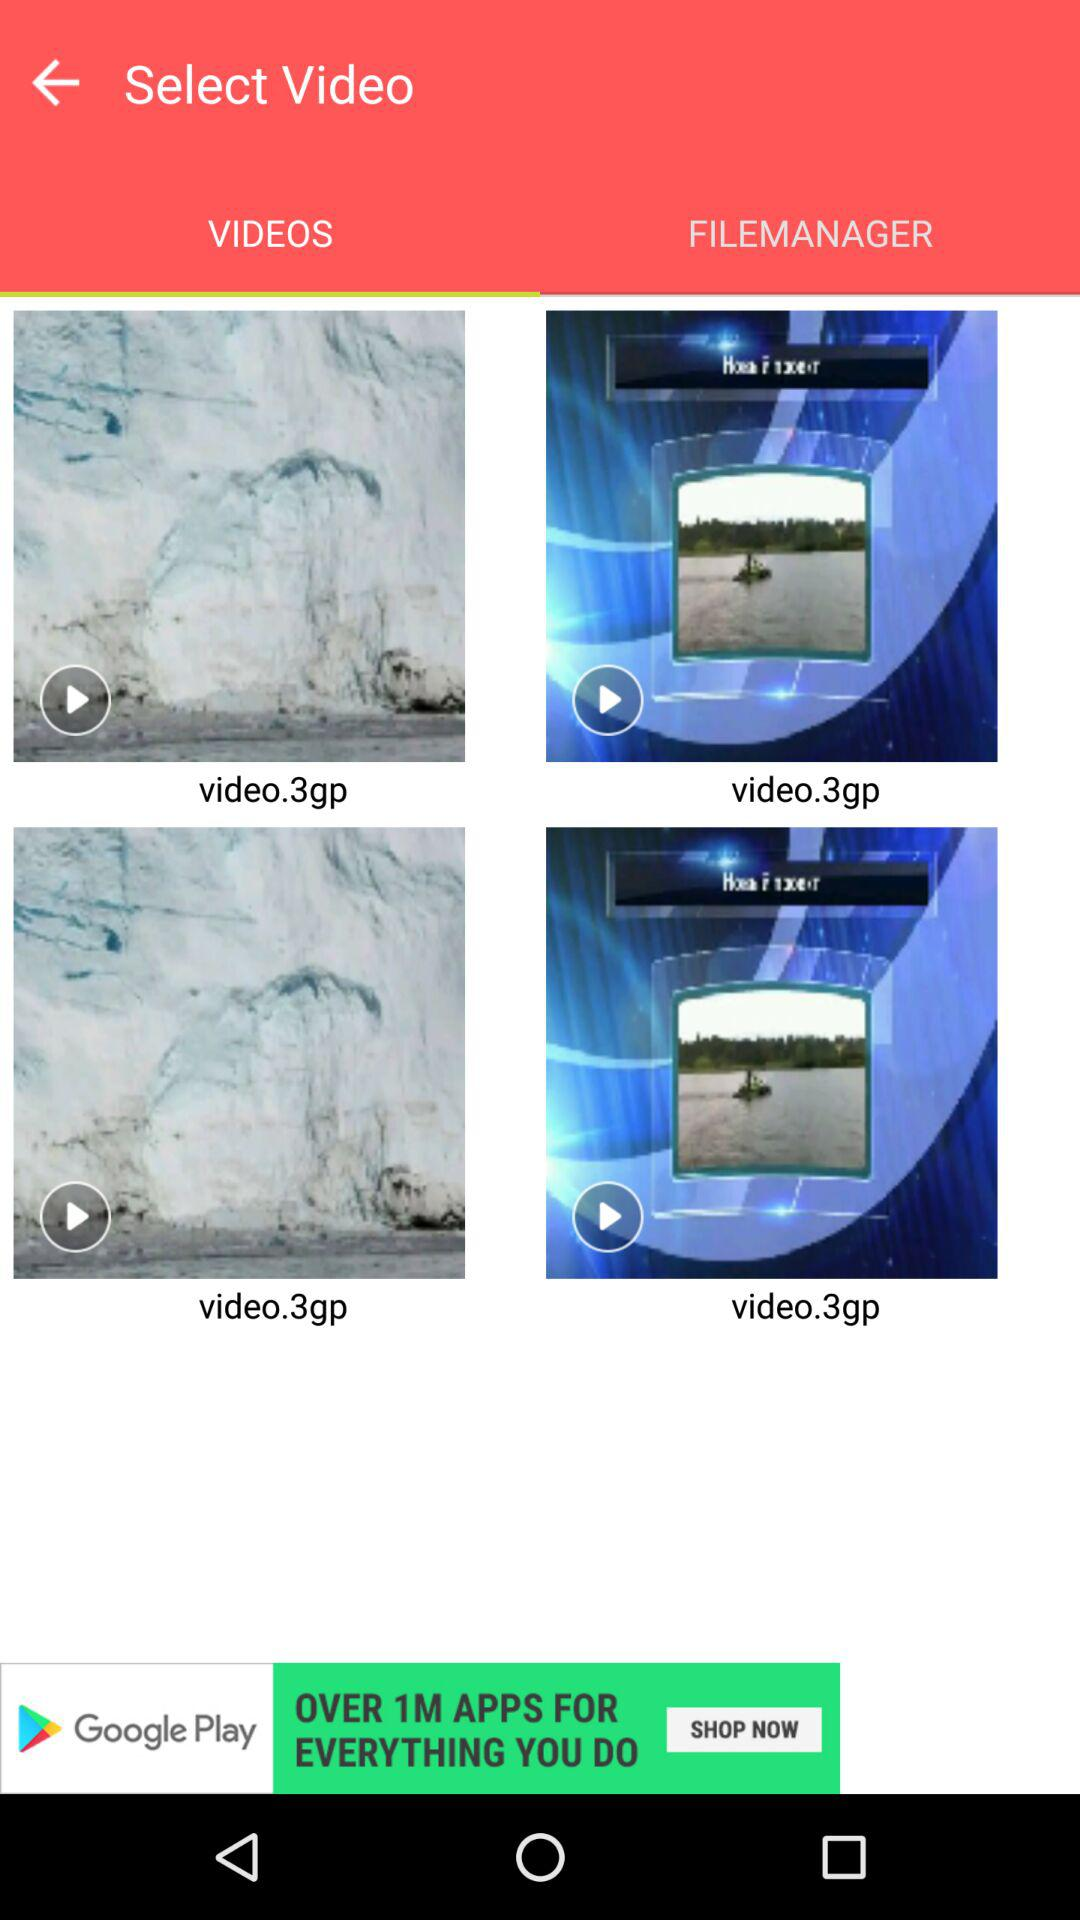What is the selected tab? The selected tab is "VIDEOS". 